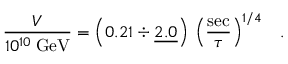<formula> <loc_0><loc_0><loc_500><loc_500>\frac { V } { 1 0 ^ { 1 0 } \, G e V } = \left ( 0 . 2 1 \div \underline { 2 . 0 } \right ) \, \left ( \frac { s e c } { \tau } \right ) ^ { 1 / 4 } \, .</formula> 